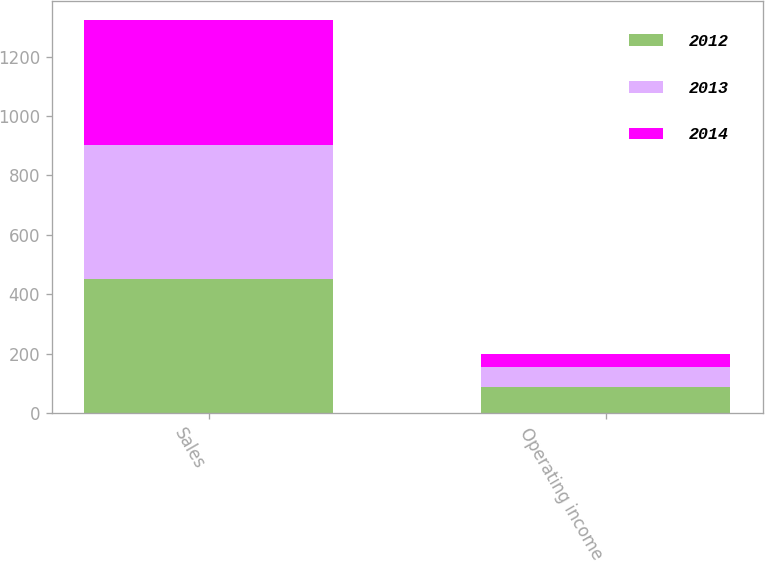Convert chart to OTSL. <chart><loc_0><loc_0><loc_500><loc_500><stacked_bar_chart><ecel><fcel>Sales<fcel>Operating income<nl><fcel>2012<fcel>450.4<fcel>88.2<nl><fcel>2013<fcel>451.1<fcel>65.5<nl><fcel>2014<fcel>420.1<fcel>44.6<nl></chart> 